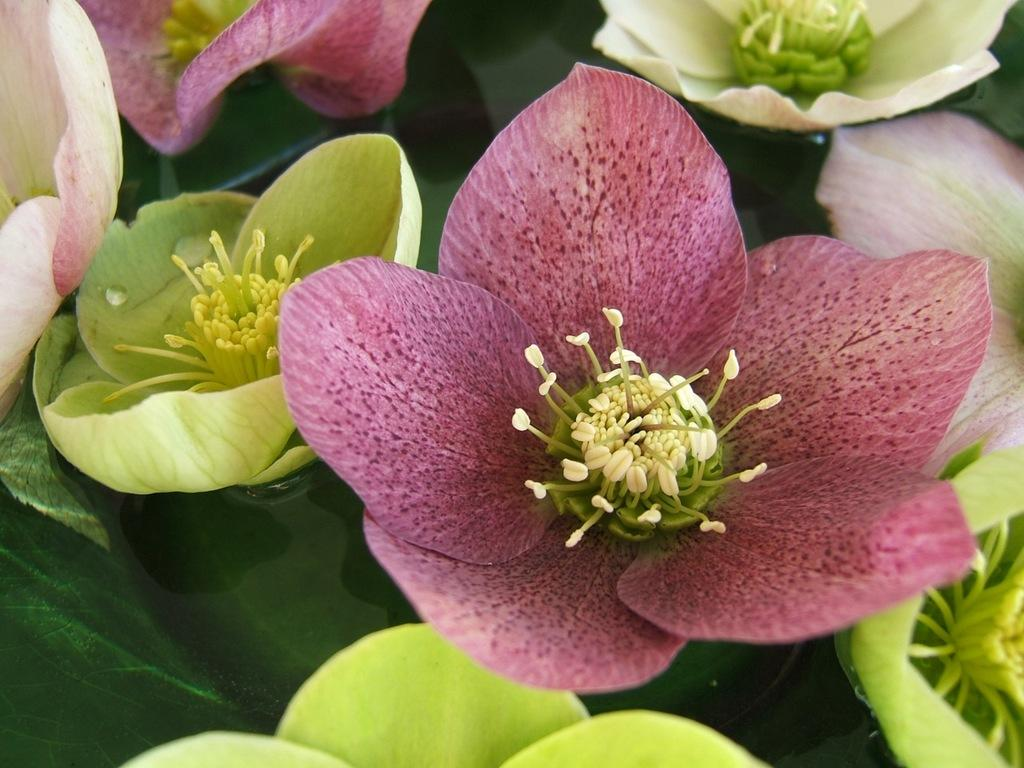What type of plant life can be seen in the image? There are flowers and leaves in the image. Can you describe the flowers in the image? Unfortunately, the facts provided do not give specific details about the flowers. Are the leaves attached to any plants or trees in the image? The facts provided do not specify whether the leaves are attached to plants or trees. What type of guitar is being played by the person wearing a skirt in the image? There is no person, guitar, or skirt present in the image; it only features flowers and leaves. 